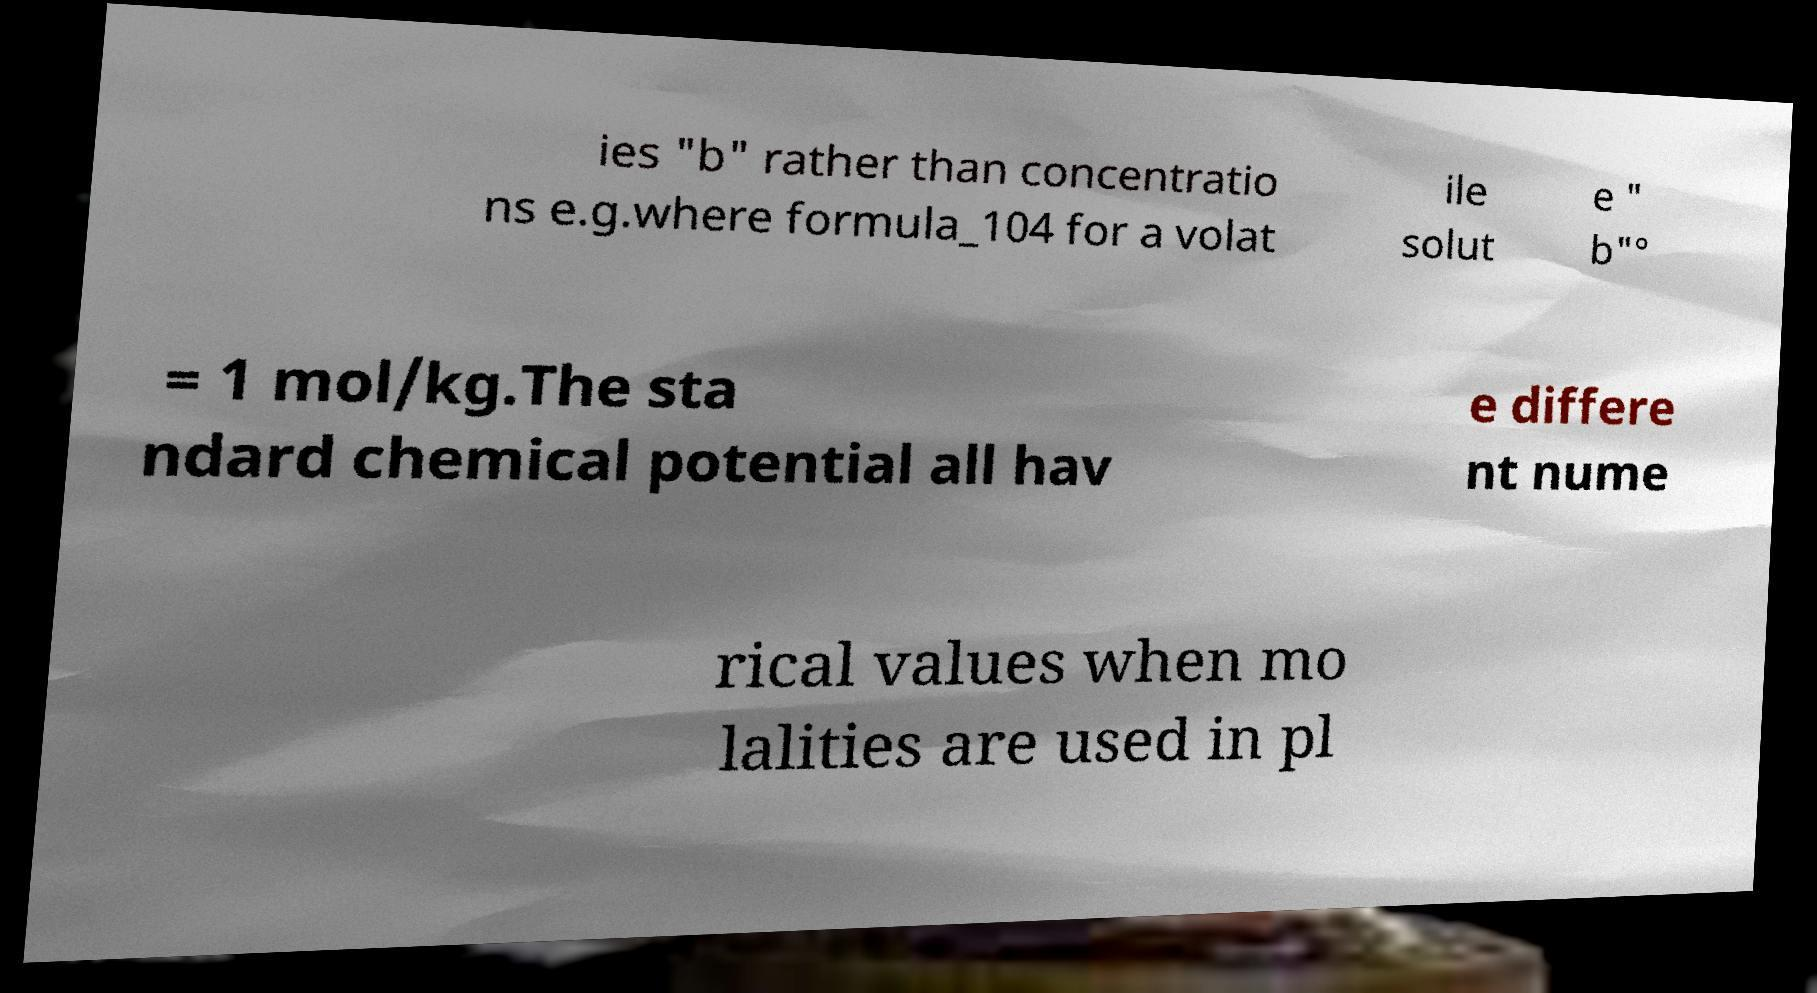There's text embedded in this image that I need extracted. Can you transcribe it verbatim? ies "b" rather than concentratio ns e.g.where formula_104 for a volat ile solut e " b"° = 1 mol/kg.The sta ndard chemical potential all hav e differe nt nume rical values when mo lalities are used in pl 